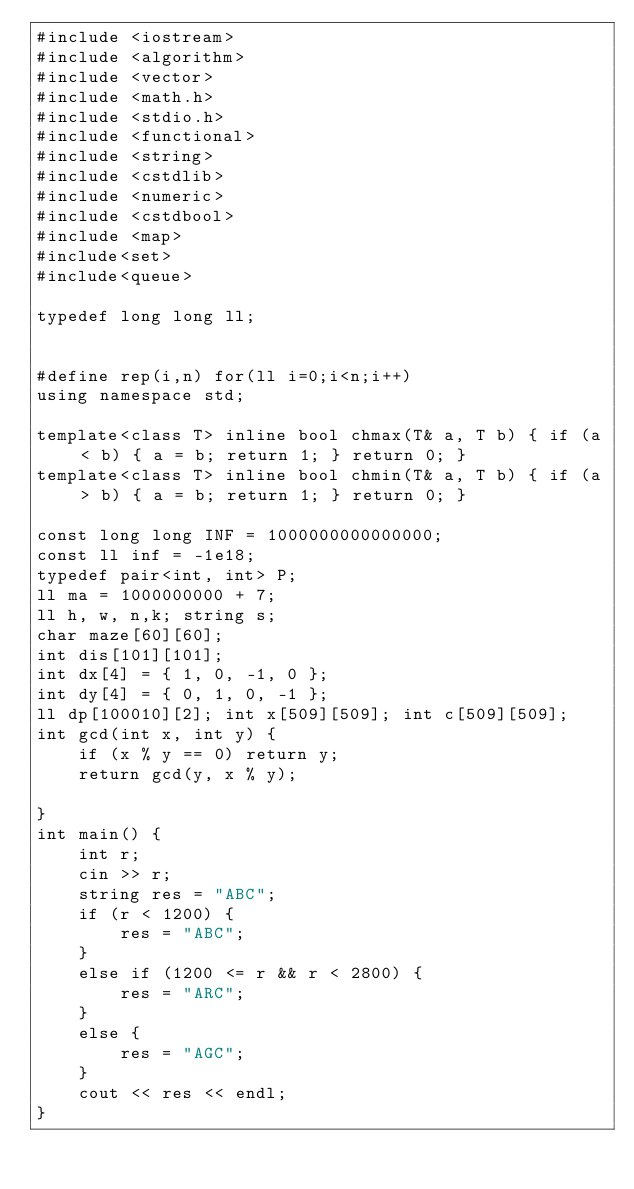<code> <loc_0><loc_0><loc_500><loc_500><_C++_>#include <iostream>
#include <algorithm>
#include <vector>
#include <math.h>
#include <stdio.h>
#include <functional>
#include <string>
#include <cstdlib>
#include <numeric>
#include <cstdbool>
#include <map> 
#include<set>
#include<queue>

typedef long long ll;


#define rep(i,n) for(ll i=0;i<n;i++)
using namespace std;

template<class T> inline bool chmax(T& a, T b) { if (a < b) { a = b; return 1; } return 0; }
template<class T> inline bool chmin(T& a, T b) { if (a > b) { a = b; return 1; } return 0; }

const long long INF = 1000000000000000;
const ll inf = -1e18;
typedef pair<int, int> P;
ll ma = 1000000000 + 7;
ll h, w, n,k; string s;
char maze[60][60];
int dis[101][101];
int dx[4] = { 1, 0, -1, 0 };
int dy[4] = { 0, 1, 0, -1 };
ll dp[100010][2]; int x[509][509]; int c[509][509];
int gcd(int x, int y) {
	if (x % y == 0) return y;
	return gcd(y, x % y);

}
int main() {
	int r;
	cin >> r;
	string res = "ABC";
	if (r < 1200) {
		res = "ABC";
	}
	else if (1200 <= r && r < 2800) {
		res = "ARC";
	}
	else {
		res = "AGC";
	}
	cout << res << endl;
}


</code> 